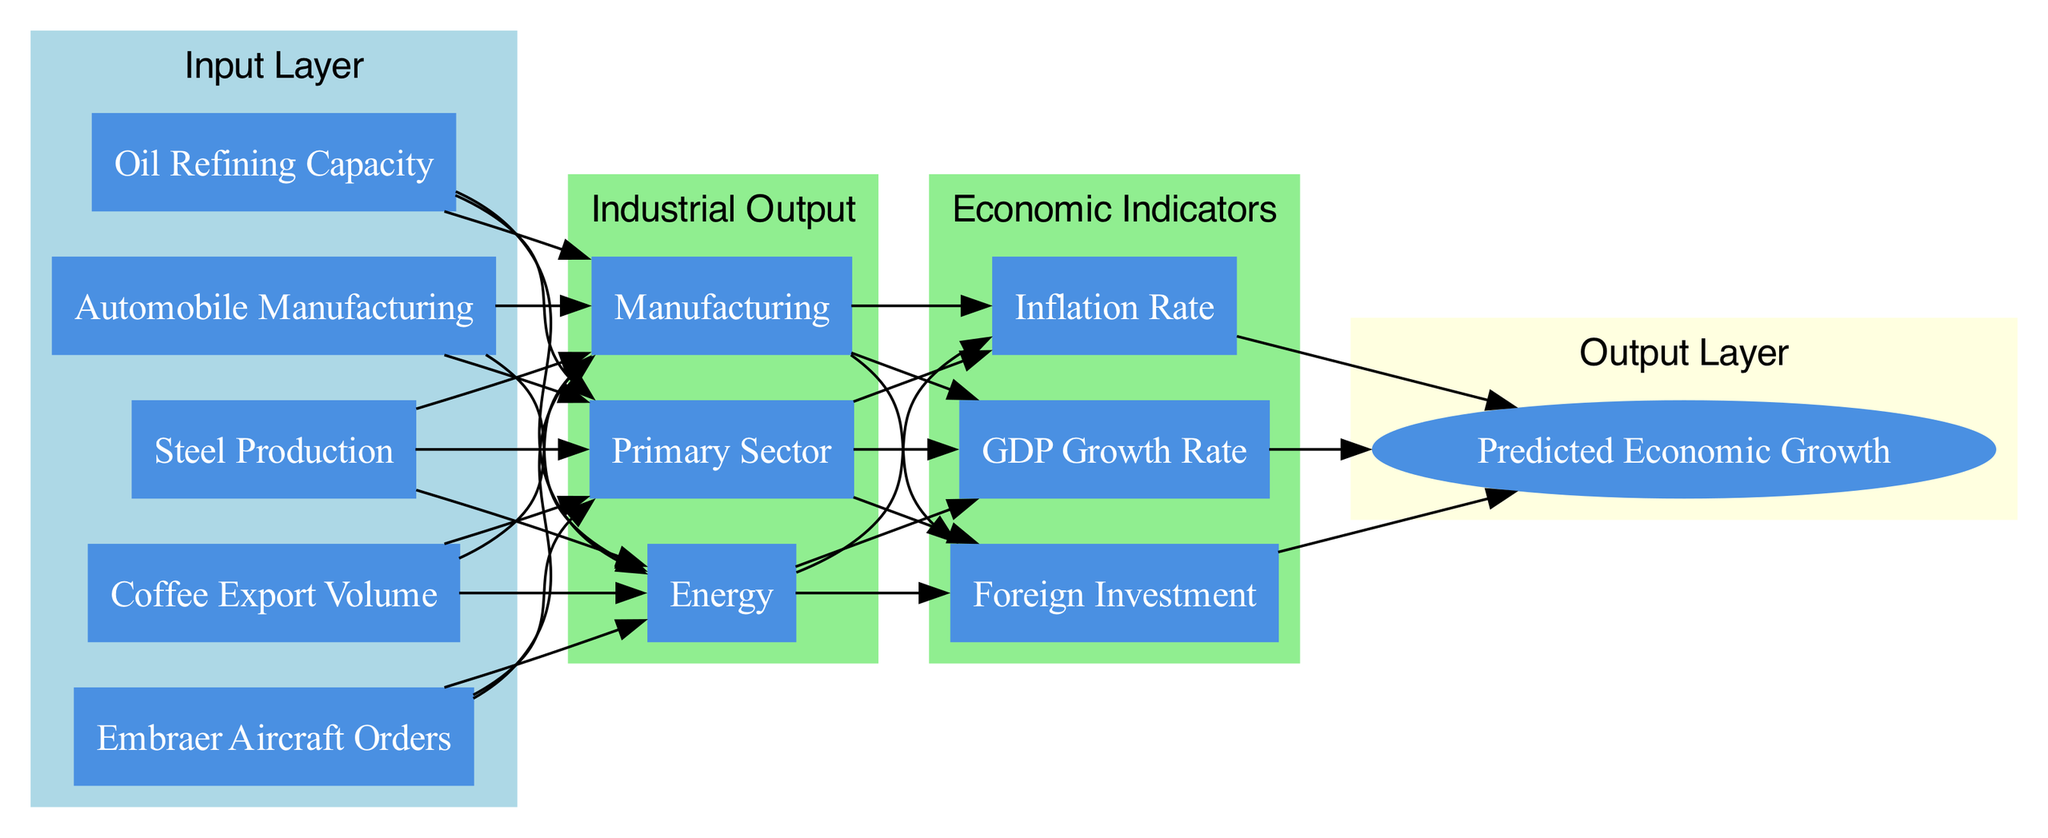What are the nodes in the input layer? The input layer has five nodes: Coffee Export Volume, Steel Production, Automobile Manufacturing, Oil Refining Capacity, and Embraer Aircraft Orders.
Answer: Coffee Export Volume, Steel Production, Automobile Manufacturing, Oil Refining Capacity, Embraer Aircraft Orders How many nodes are in the hidden layer "Industrial Output"? The hidden layer "Industrial Output" contains three nodes: Primary Sector, Manufacturing, and Energy.
Answer: 3 What is the connection from the input layer to the first hidden layer? The connection from the input layer to the first hidden layer is represented by edges linking each input node to the nodes in "Industrial Output" layer.
Answer: Input to Industrial Output Which hidden layer connects directly to the output layer? The "Economic Indicators" hidden layer connects directly to the output layer.
Answer: Economic Indicators What economic indicators are included in the second hidden layer? The second hidden layer includes three economic indicators: GDP Growth Rate, Inflation Rate, and Foreign Investment.
Answer: GDP Growth Rate, Inflation Rate, Foreign Investment What is the output of the neural network? The output of the neural network is "Predicted Economic Growth."
Answer: Predicted Economic Growth How many connections lead from the "Industrial Output" layer to the "Economic Indicators" layer? There are three connections that lead from the "Industrial Output" layer to the "Economic Indicators" layer, with each node in "Industrial Output" connecting to every node in "Economic Indicators."
Answer: 3 What is the total number of layers in the diagram? The diagram has three layers: an input layer, two hidden layers, and one output layer.
Answer: 3 